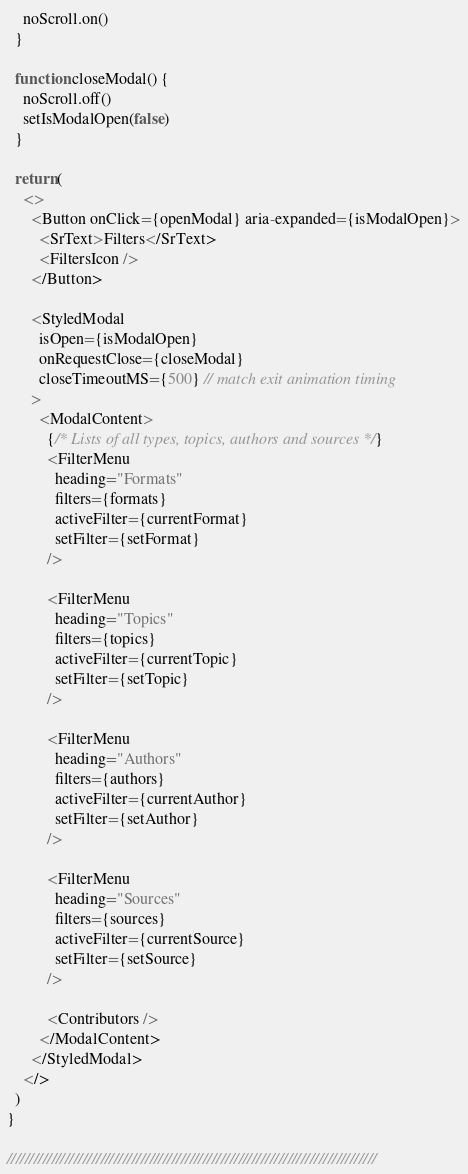Convert code to text. <code><loc_0><loc_0><loc_500><loc_500><_JavaScript_>    noScroll.on()
  }

  function closeModal() {
    noScroll.off()
    setIsModalOpen(false)
  }

  return (
    <>
      <Button onClick={openModal} aria-expanded={isModalOpen}>
        <SrText>Filters</SrText>
        <FiltersIcon />
      </Button>

      <StyledModal
        isOpen={isModalOpen}
        onRequestClose={closeModal}
        closeTimeoutMS={500} // match exit animation timing
      >
        <ModalContent>
          {/* Lists of all types, topics, authors and sources */}
          <FilterMenu
            heading="Formats"
            filters={formats}
            activeFilter={currentFormat}
            setFilter={setFormat}
          />

          <FilterMenu
            heading="Topics"
            filters={topics}
            activeFilter={currentTopic}
            setFilter={setTopic}
          />

          <FilterMenu
            heading="Authors"
            filters={authors}
            activeFilter={currentAuthor}
            setFilter={setAuthor}
          />

          <FilterMenu
            heading="Sources"
            filters={sources}
            activeFilter={currentSource}
            setFilter={setSource}
          />

          <Contributors />
        </ModalContent>
      </StyledModal>
    </>
  )
}

///////////////////////////////////////////////////////////////////////////////////
</code> 